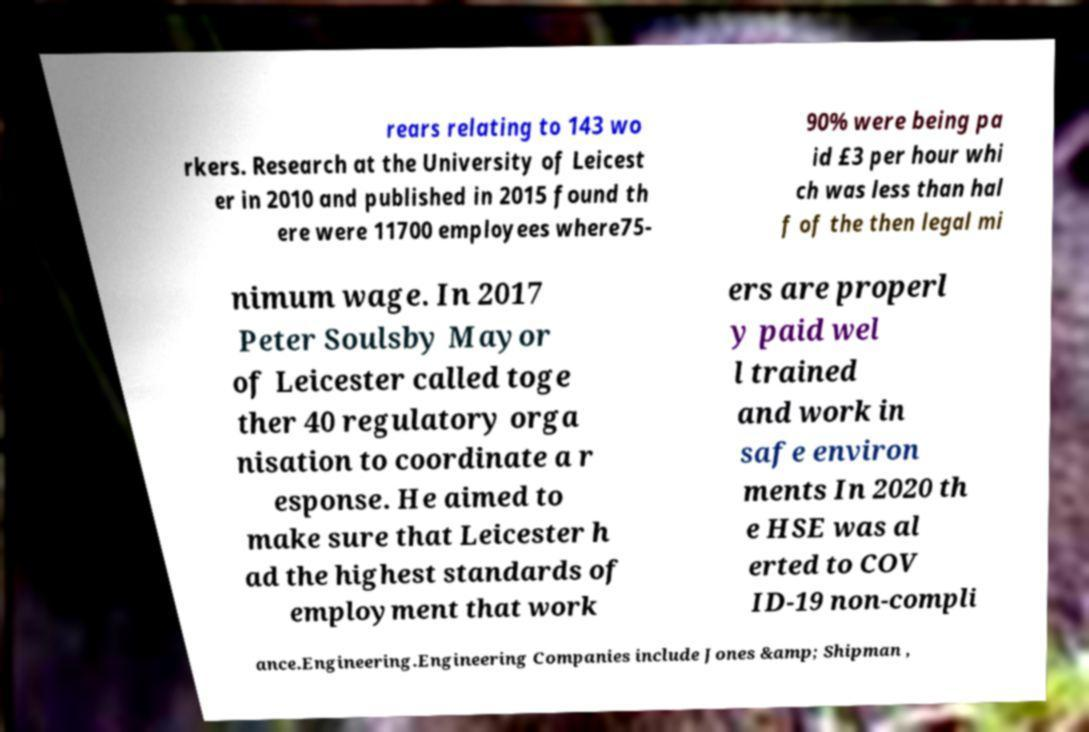Can you accurately transcribe the text from the provided image for me? rears relating to 143 wo rkers. Research at the University of Leicest er in 2010 and published in 2015 found th ere were 11700 employees where75- 90% were being pa id £3 per hour whi ch was less than hal f of the then legal mi nimum wage. In 2017 Peter Soulsby Mayor of Leicester called toge ther 40 regulatory orga nisation to coordinate a r esponse. He aimed to make sure that Leicester h ad the highest standards of employment that work ers are properl y paid wel l trained and work in safe environ ments In 2020 th e HSE was al erted to COV ID-19 non-compli ance.Engineering.Engineering Companies include Jones &amp; Shipman , 